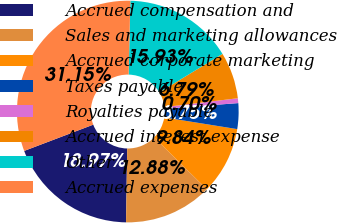Convert chart. <chart><loc_0><loc_0><loc_500><loc_500><pie_chart><fcel>Accrued compensation and<fcel>Sales and marketing allowances<fcel>Accrued corporate marketing<fcel>Taxes payable<fcel>Royalties payable<fcel>Accrued interest expense<fcel>Other<fcel>Accrued expenses<nl><fcel>18.97%<fcel>12.88%<fcel>9.84%<fcel>3.75%<fcel>0.7%<fcel>6.79%<fcel>15.93%<fcel>31.15%<nl></chart> 